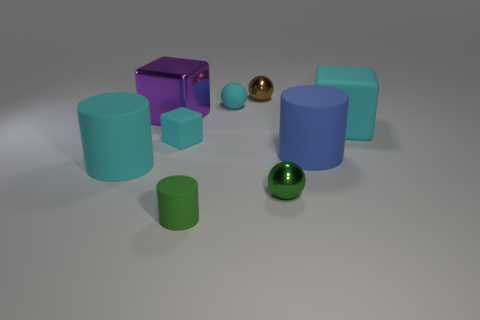Subtract all balls. How many objects are left? 6 Add 9 green spheres. How many green spheres exist? 10 Subtract 0 yellow cylinders. How many objects are left? 9 Subtract all large purple shiny cylinders. Subtract all big blue cylinders. How many objects are left? 8 Add 4 blue things. How many blue things are left? 5 